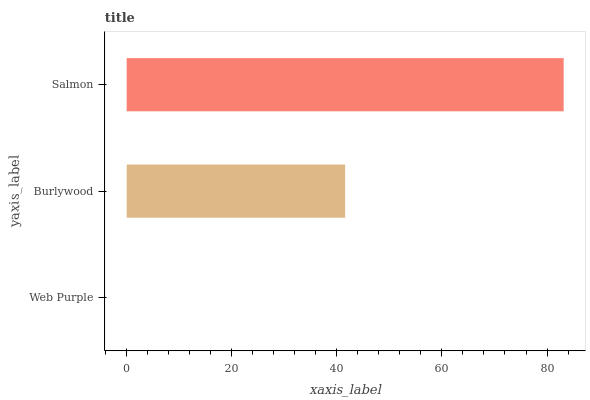Is Web Purple the minimum?
Answer yes or no. Yes. Is Salmon the maximum?
Answer yes or no. Yes. Is Burlywood the minimum?
Answer yes or no. No. Is Burlywood the maximum?
Answer yes or no. No. Is Burlywood greater than Web Purple?
Answer yes or no. Yes. Is Web Purple less than Burlywood?
Answer yes or no. Yes. Is Web Purple greater than Burlywood?
Answer yes or no. No. Is Burlywood less than Web Purple?
Answer yes or no. No. Is Burlywood the high median?
Answer yes or no. Yes. Is Burlywood the low median?
Answer yes or no. Yes. Is Web Purple the high median?
Answer yes or no. No. Is Web Purple the low median?
Answer yes or no. No. 